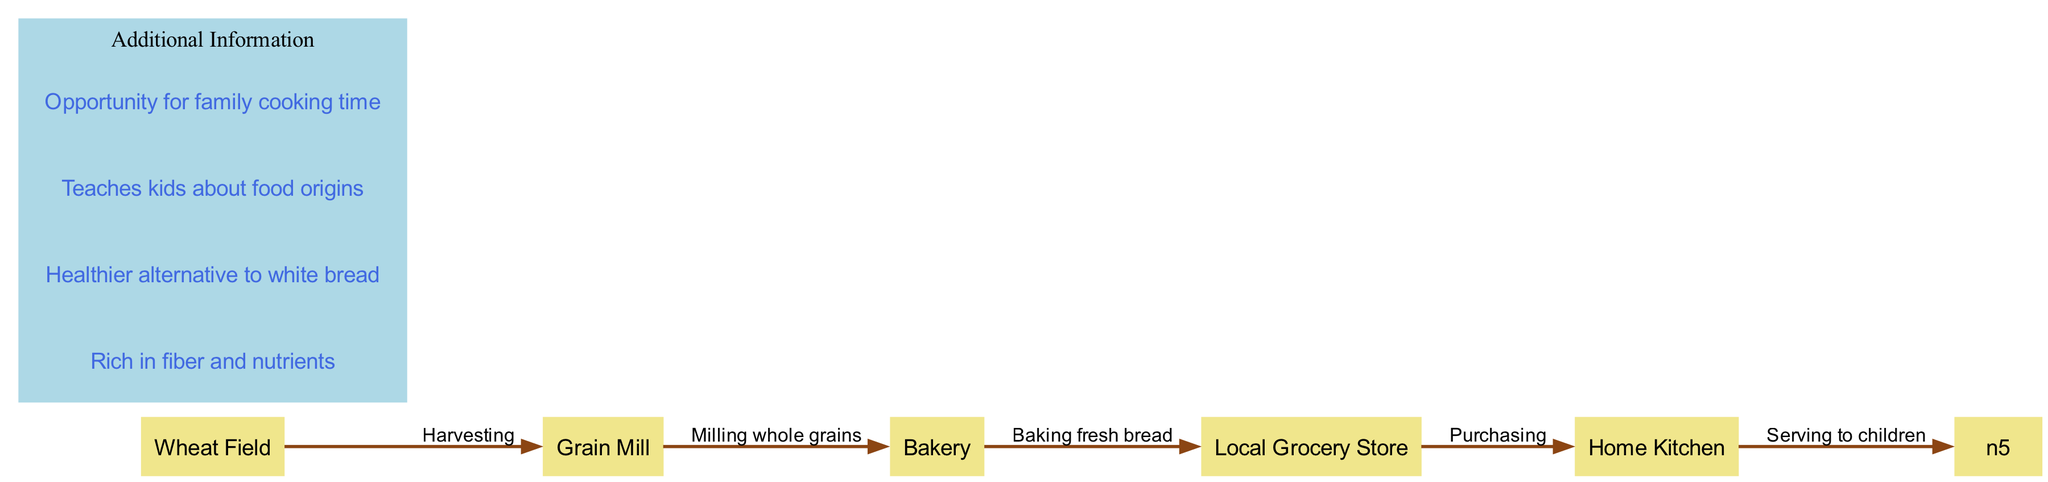What is the first node in the production process? The first node in the production process is "Wheat Field" where the wheat is grown and harvested.
Answer: Wheat Field How many nodes are present in the diagram? The diagram has a total of 5 nodes representing different stages from wheat to bread.
Answer: 5 What edge connects the "Grain Mill" and "Bakery"? The edge connecting these two nodes is "Baking fresh bread," representing the process of turning flour into baked goods.
Answer: Baking fresh bread Which node is directly before the "Local Grocery Store"? The node directly before "Local Grocery Store" is "Bakery," indicating that baked goods come from the bakery to the grocery store.
Answer: Bakery What is the relationship between "Home Kitchen" and "Serving to children"? "Home Kitchen" is the final node in the diagram, and the edge "Serving to children" indicates that the food prepared in the kitchen is served to the kids.
Answer: Serving to children How many edges represent the stages in the production process? There are 4 edges in the diagram which depict transitions between the various stages in the process of producing whole grain bread.
Answer: 4 What does "Milling whole grains" represent in the diagram? "Milling whole grains" is the process where harvested wheat is ground up to produce flour for baking, connecting the "Wheat Field" to the "Grain Mill."
Answer: Milling whole grains What is the significance of whole grain bread over white bread according to the additional information? The significance is that whole grain bread is a healthier alternative to white bread, enriched with more nutrients and fiber.
Answer: Healthier alternative to white bread What does the diagram suggest about the learning experience for kids? The diagram suggests that making bread teaches kids about food origins, enhancing their understanding of where their food comes from.
Answer: Teaches kids about food origins 